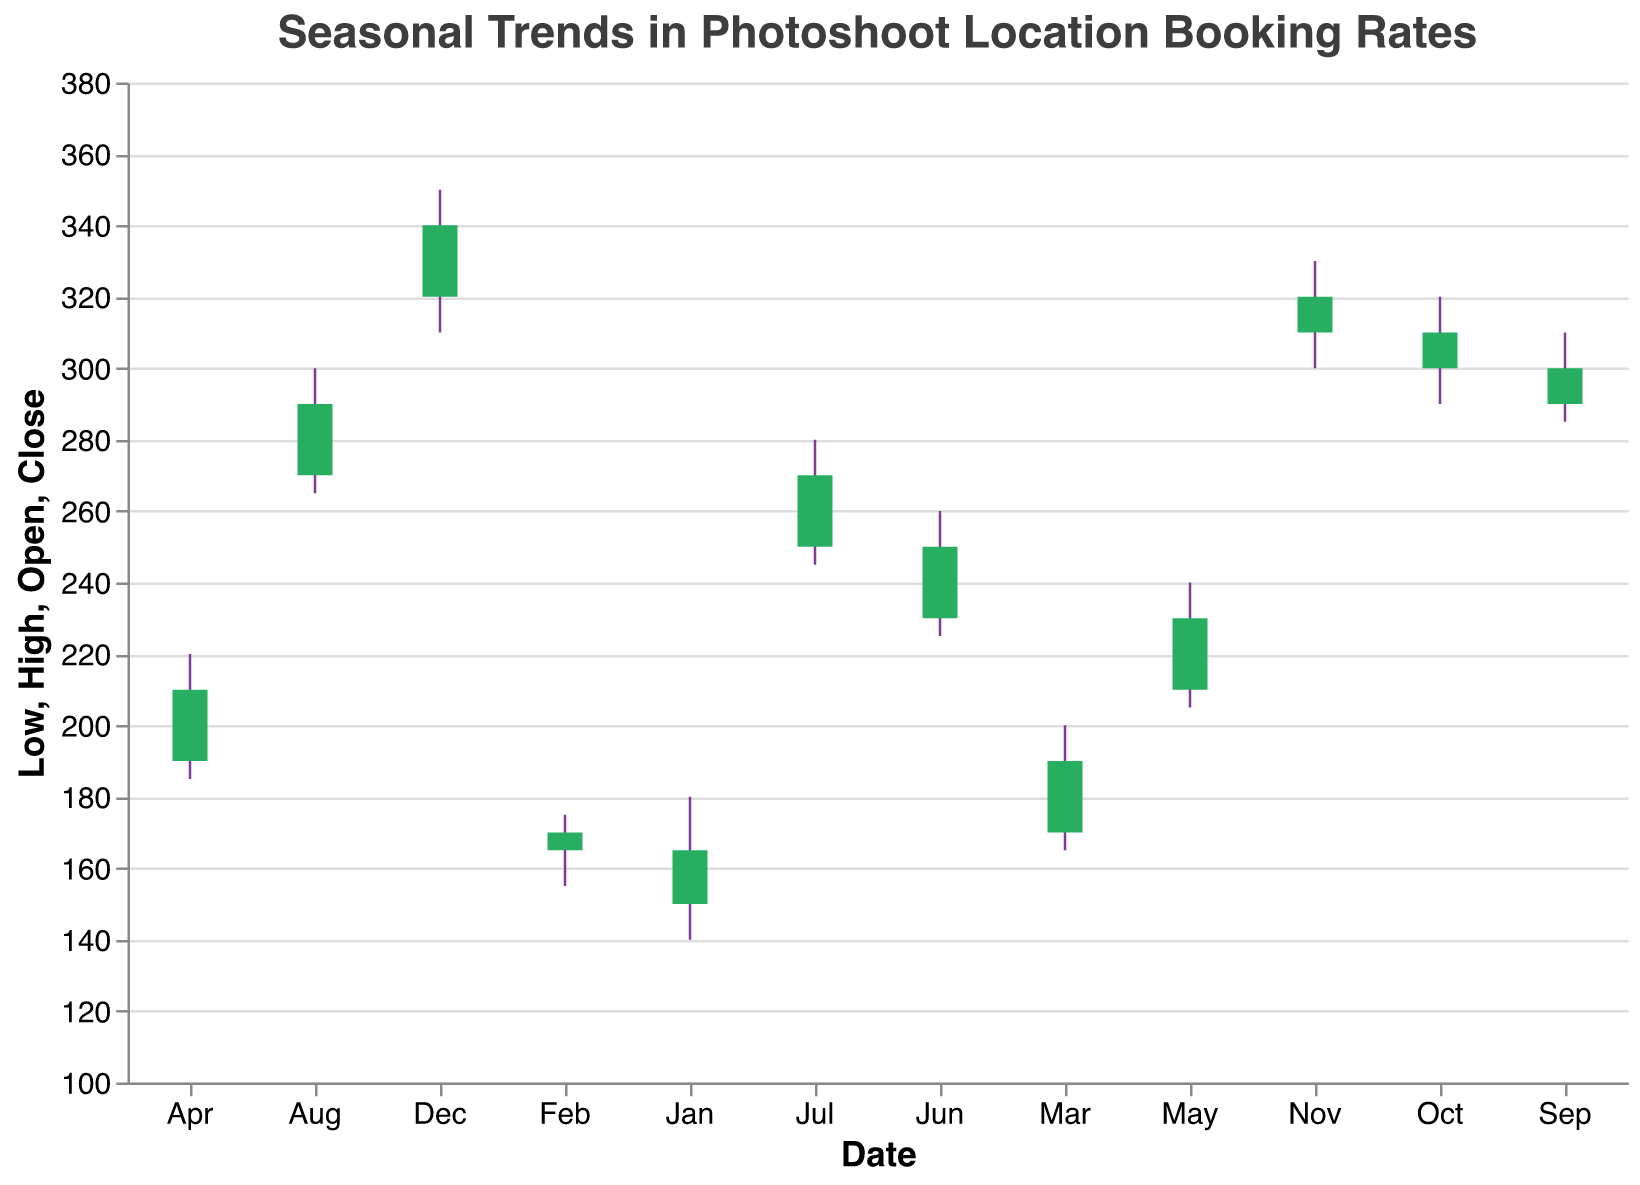What is the title of the chart? The title of the chart is at the top and it reads: "Seasonal Trends in Photoshoot Location Booking Rates"
Answer: Seasonal Trends in Photoshoot Location Booking Rates What is the highest booking rate in December? The highest booking rate in December is given by the "High" value for December, which is 350.
Answer: 350 What months show an increase in the closing price compared to the opening price? To determine the months with an increase, look at the months where the "Close" value is higher than the "Open" value. These months are: Jan (165 > 150), Feb (170 > 165), Mar (190 > 170), Apr (210 > 190), May (230 > 210), Jun (250 > 230), Jul (270 > 250), Aug (290 > 270), Sep (300 > 290), Oct (310 > 300), Nov (320 > 310), and Dec (340 > 320).
Answer: All months Which month has the greatest difference between the high and low booking rates? Calculate the difference between the "High" and "Low" values for each month and identify the maximum. December has the highest difference: 350 - 310 = 40.
Answer: December How does the closing price in April compare to the opening price in May? The closing price in April (210) is less than the opening price in May (210). This is seen by directly comparing the "Close" for April and the "Open" for May.
Answer: Less than What is the average closing price for the first quarter of the year? First quarter includes Jan, Feb, and Mar. The closing prices are 165, 170, and 190 respectively. Calculate the average: (165 + 170 + 190) / 3 = 525 / 3 = 175.
Answer: 175 Which month has the highest closing price and what is the value? The highest closing price can be identified by looking at all "Close" values. December has the highest closing price with a value of 340.
Answer: December, 340 What is the overall trend in booking rates from January to December? The overall trend can be seen by observing the increase or decrease in rates over the months. The data shows a consistent increase in closing prices from January (165) to December (340).
Answer: Increasing In which month does the booking rate show the smallest range between the high and the low values, and what is that range? Calculate the range (High - Low) for each month and identify the month with the smallest range. February has the smallest range: 175 - 155 = 20.
Answer: February, 20 